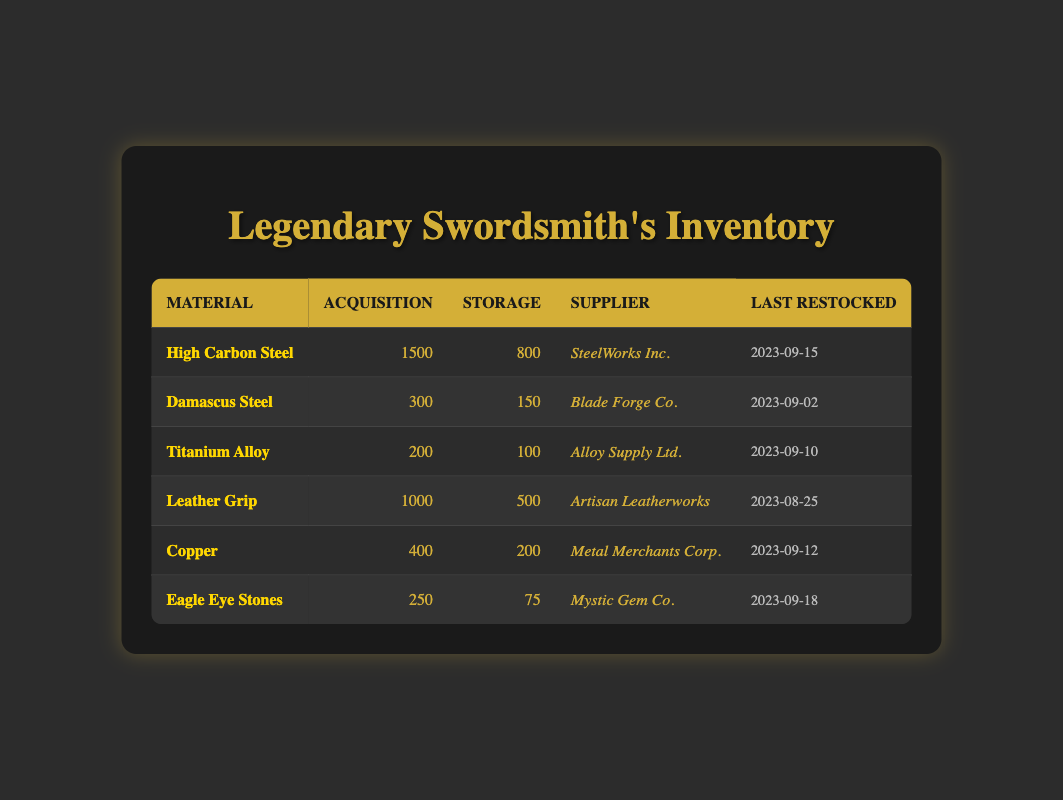What is the acquisition level of High Carbon Steel? The acquisition level of High Carbon Steel is listed directly in the table under the acquisition column, which states that it is 1500.
Answer: 1500 Which material has the lowest storage level? When reviewing the storage levels of all materials in the table, Eagle Eye Stones has the lowest storage level of 75, as compared to others.
Answer: Eagle Eye Stones How much total acquisition level do we have for all materials? To find the total acquisition level, sum the acquisition levels: 1500 + 300 + 200 + 1000 + 400 + 250 = 2650.
Answer: 2650 Is Copper supplied by Metal Merchants Corp.? The supplier for Copper is listed in the table as Metal Merchants Corp., confirming the statement is true.
Answer: Yes What is the difference between the acquisition level of Leather Grip and that of Titanium Alloy? The acquisition level of Leather Grip is 1000, and the acquisition level of Titanium Alloy is 200. The difference is calculated as 1000 - 200 = 800.
Answer: 800 Which supplier provides more than one type of material? Reviewing the supplier information across the materials, each supplier only supplies one type of material according to the table.
Answer: No What is the average storage level across all materials? The storage levels are 800, 150, 100, 500, 200, and 75. The sum is 1825 and the average is calculated by dividing by 6 (the number of materials), which gives 1825 / 6 ≈ 304.17.
Answer: 304.17 Which material was last restocked on September 18, 2023? Checking the "Last Restocked" column, it is evident that Eagle Eye Stones was last restocked on September 18, 2023.
Answer: Eagle Eye Stones How many materials have acquisition levels greater than 250? Examining the acquisition levels, the materials with levels greater than 250 are High Carbon Steel, Leather Grip, and Copper. This gives a total count of 3 materials.
Answer: 3 